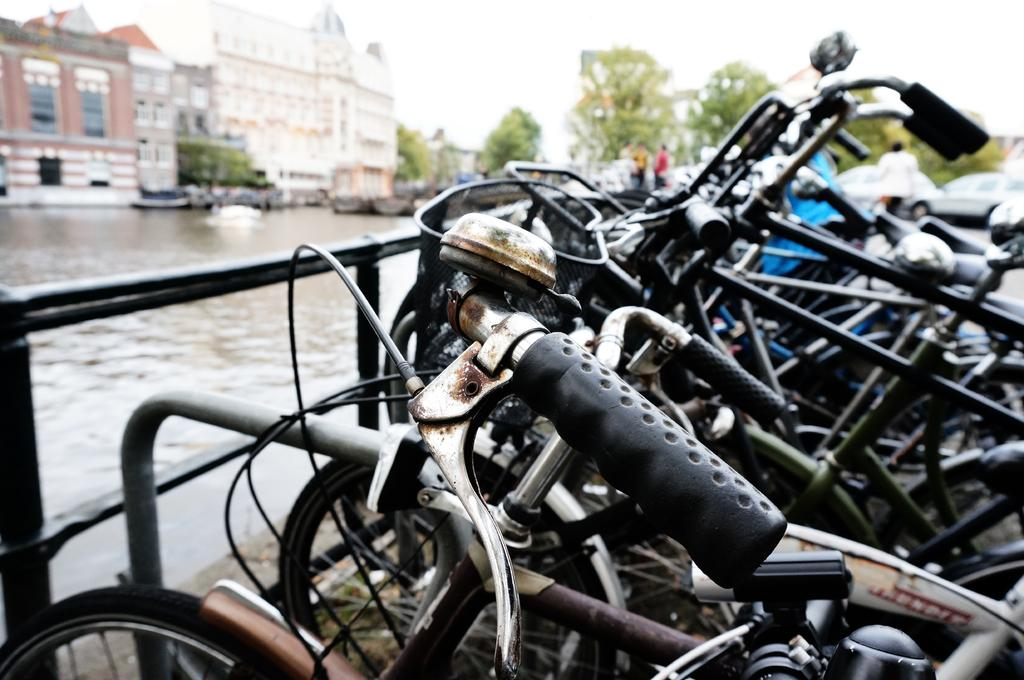What is being transported on the water surface in the image? There are vehicles in a boat in the image. What type of watercraft is present in the image? There are boats on the water surface in the image. What can be seen in the background of the image? There are trees and buildings visible in the image. What type of mine can be seen in the image? There is no mine present in the image. How many boards are visible in the image? There is no reference to boards in the image. 